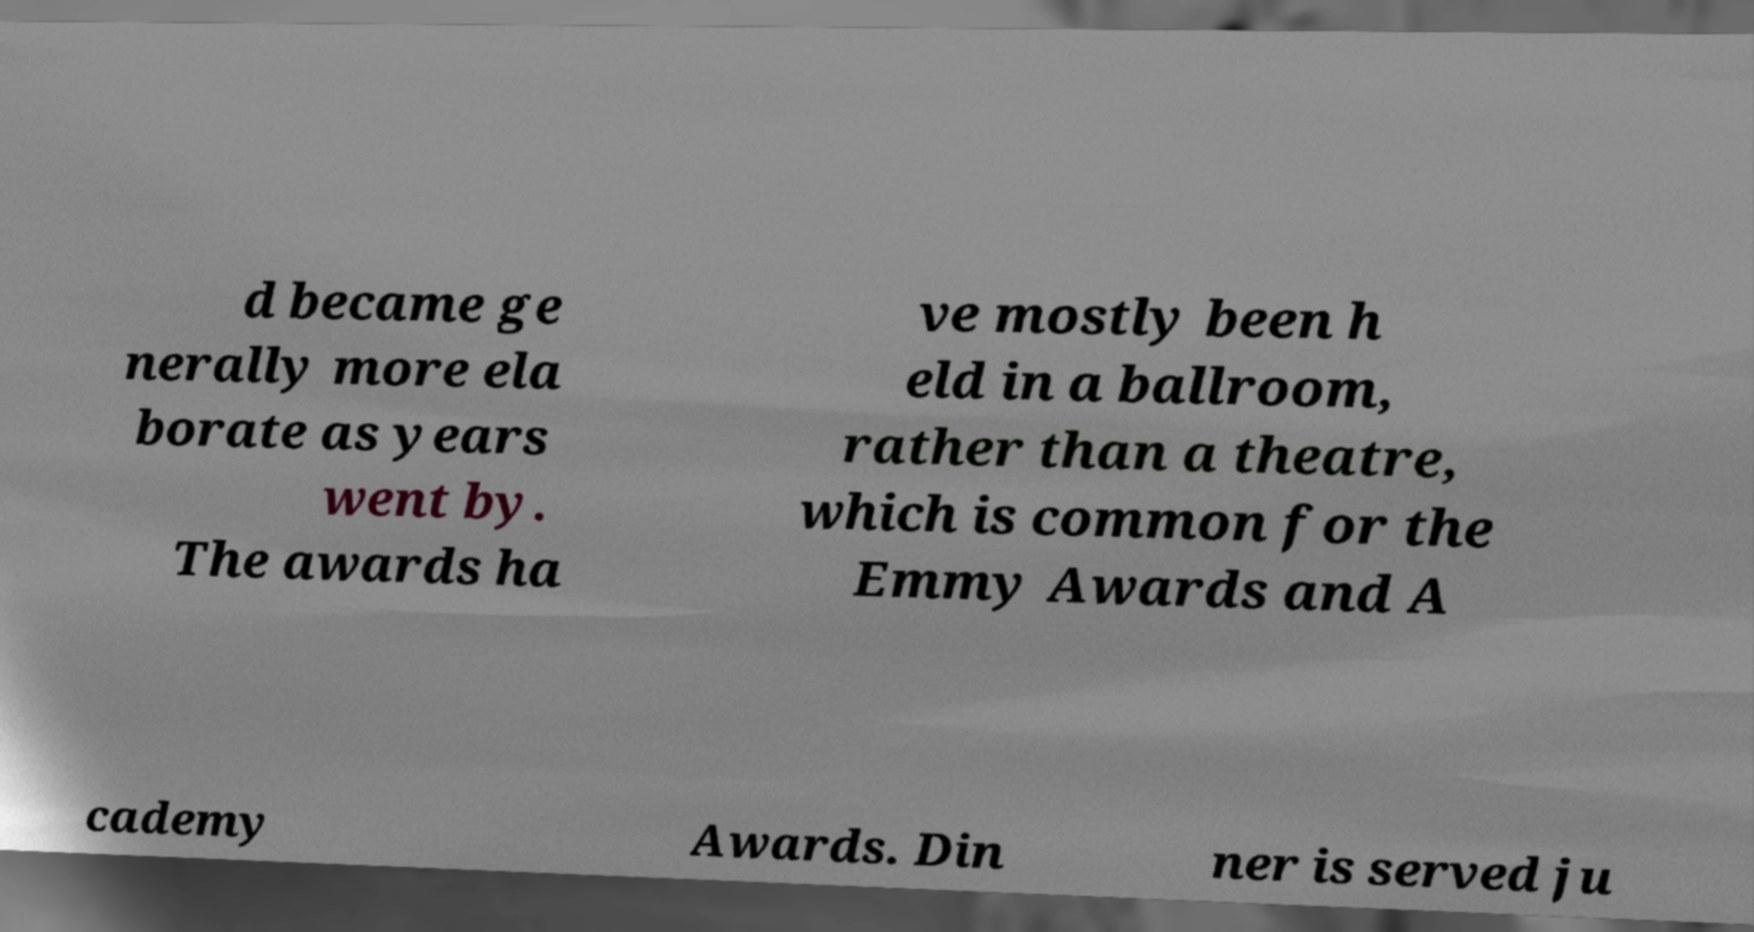Can you read and provide the text displayed in the image?This photo seems to have some interesting text. Can you extract and type it out for me? d became ge nerally more ela borate as years went by. The awards ha ve mostly been h eld in a ballroom, rather than a theatre, which is common for the Emmy Awards and A cademy Awards. Din ner is served ju 